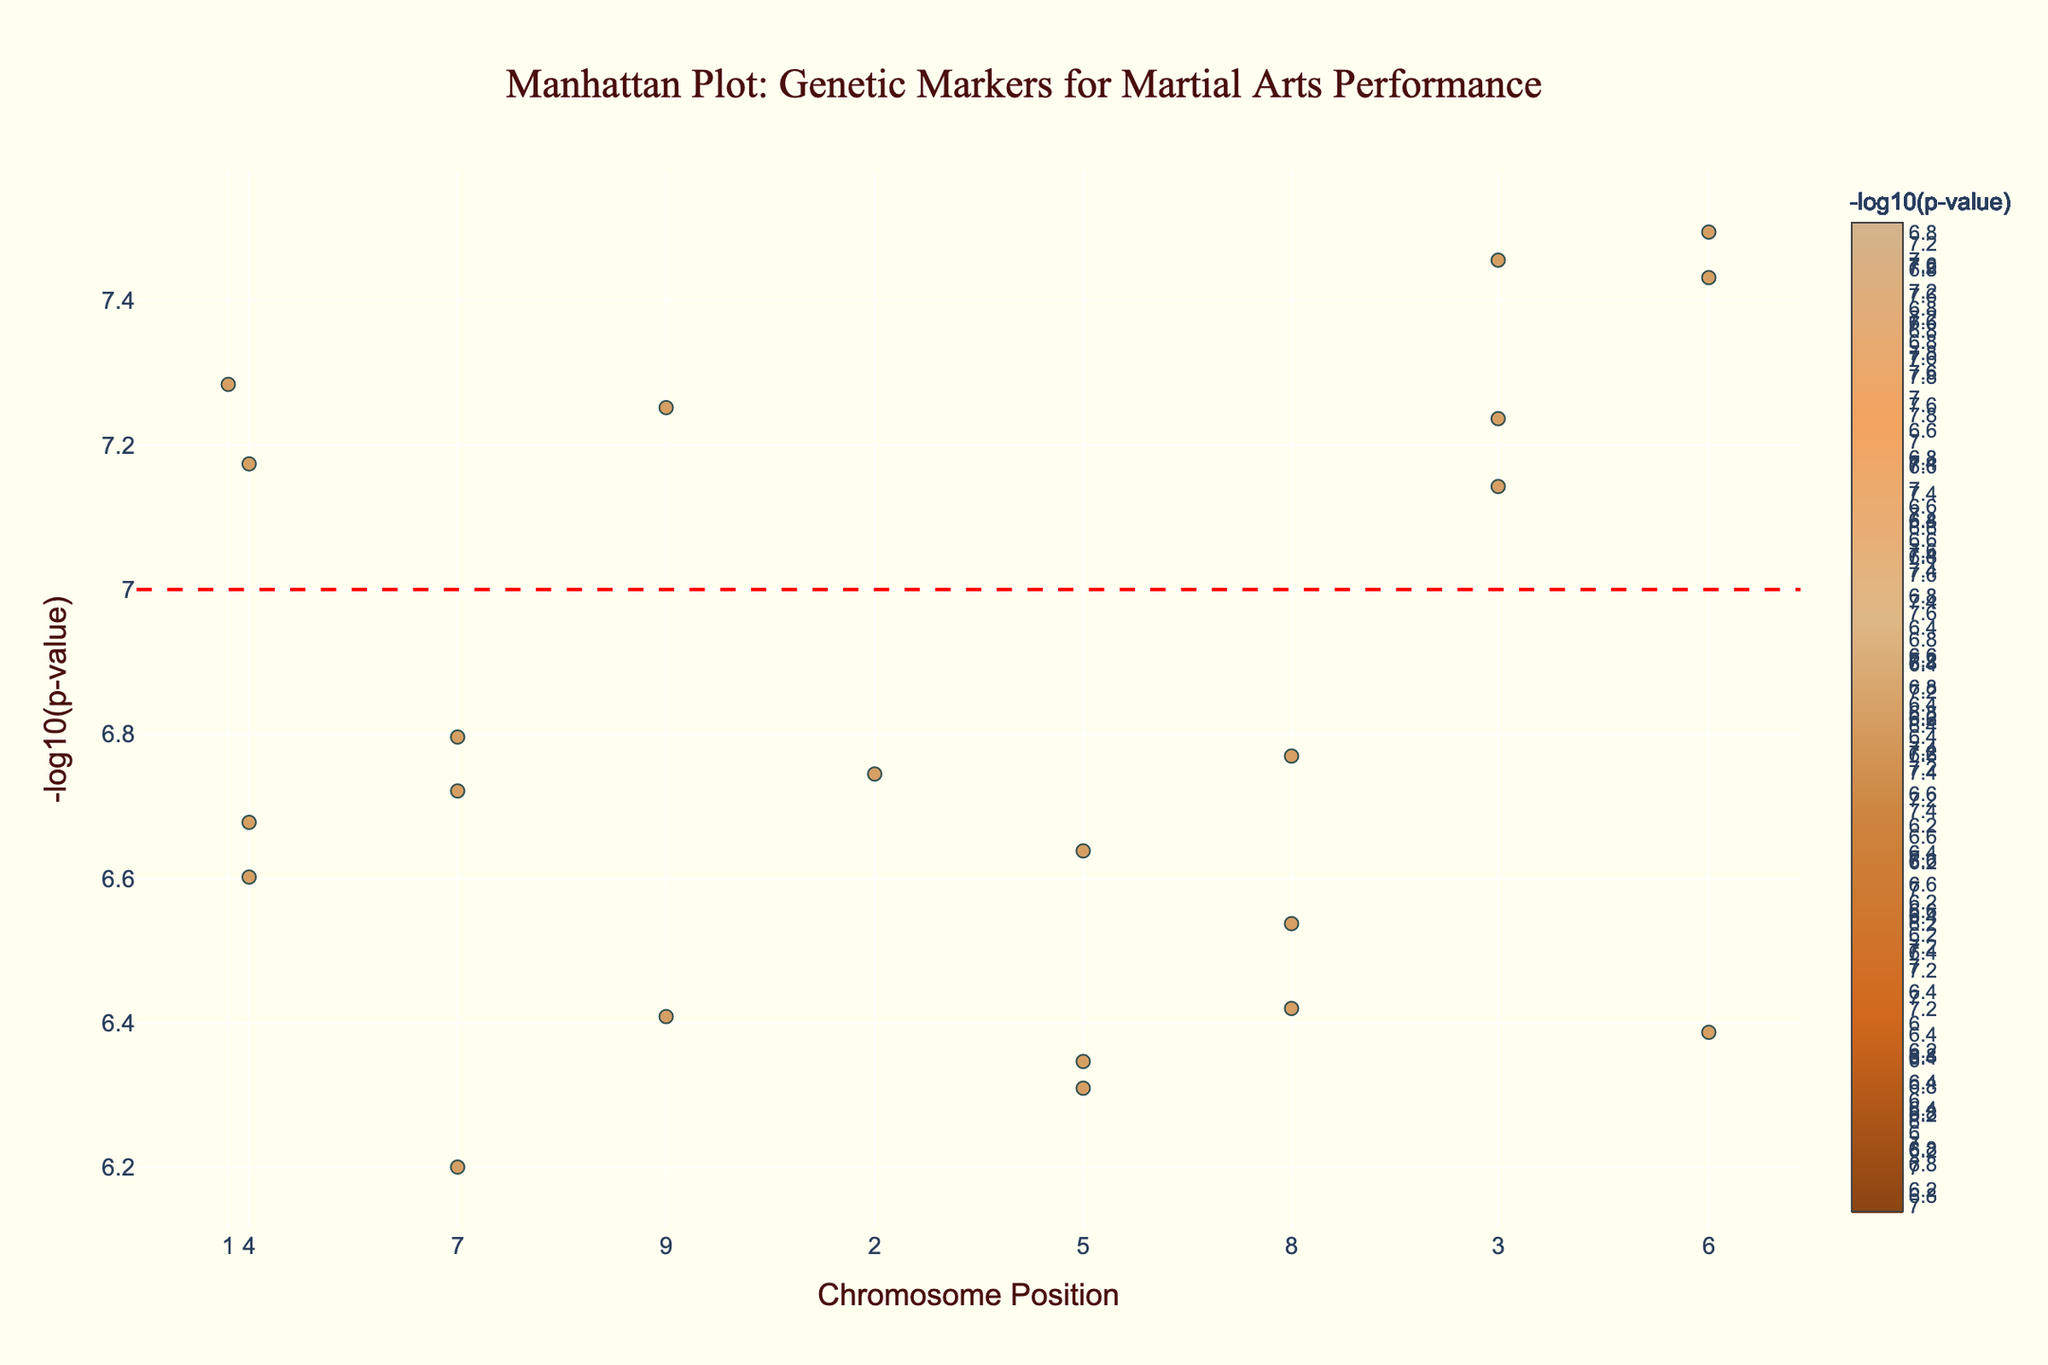what is the title of the figure? The title of the figure is usually displayed at the top and specifies the main topic or purpose of the plot. In this case, it is "Manhattan Plot: Genetic Markers for Martial Arts Performance".
Answer: Manhattan Plot: Genetic Markers for Martial Arts Performance what is the y-axis label of the plot? The y-axis label is located along the vertical axis of the plot and indicates what the axis values represent. Here, it is "-log10(p-value)".
Answer: -log10(p-value) Which genetic marker has the lowest P_value? The marker with the lowest P_value will have the highest -log10(p_value), as it appears at the top of the plot. Comparing all the markers, the gene ACTN3 on chromosome 1 has the highest -log10(p) value of 7.284.
Answer: ACTN3 How many chromosomes have been analyzed in the plot? Each unique chromosome is represented along the x-axis. Counting these unique chromosome labels gives us the total number of analyzed chromosomes, which is 22.
Answer: 22 Which trait corresponds to the genetic marker with the highest -log10(p-value)? The highest -log10(p-value) corresponds to the lowest P_value. The gene ACTN3 has the highest value of 7.284, corresponding to the trait Explosive power.
Answer: Explosive power Which chromosome has the most significant marker for Red blood cell production? Identify the gene associated with Red blood cell production and find its position and chromosome. Gene EPOR on chromosome 15 is associated with Red blood cell production. The plot indicates this marker as significant.
Answer: Chromosome 15 What is the significance threshold indicated by the horizontal line in the plot? The horizontal line represents a common threshold used to indicate significant markers in GWAS. The y-intercept of this line is 7, indicating the significance threshold at -log10(p-value) of 7.
Answer: 7 Which gene is associated with the trait Joint flexibility, and on which chromosome is it located? Check the list for the gene related to Joint flexibility. Gene GDF5 appears, located on chromosome 14.
Answer: GDF5; Chromosome 14 Compare the -log10(p-value) of genes linked to Endurance and Cardiovascular fitness. Which one is more significant? Endurance is linked to PPARA with a -log10(p-value) of 6.743, and Cardiovascular fitness is linked to ACE with a -log10(p-value) of 7.456. Since a higher -log10(p-value) indicates more significance, ACE (Cardiovascular fitness) is more significant.
Answer: Cardiovascular fitness 